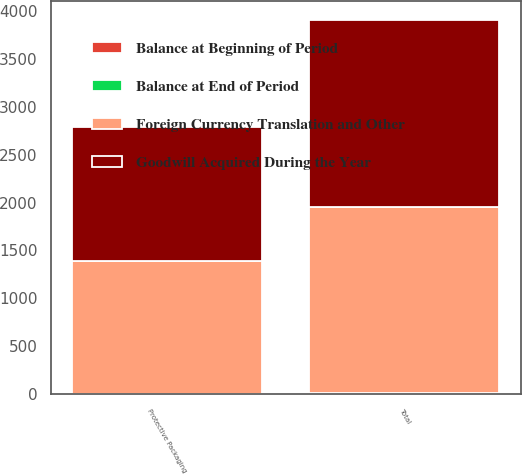Convert chart to OTSL. <chart><loc_0><loc_0><loc_500><loc_500><stacked_bar_chart><ecel><fcel>Protective Packaging<fcel>Total<nl><fcel>Foreign Currency Translation and Other<fcel>1392.3<fcel>1939.5<nl><fcel>Balance at End of Period<fcel>2.3<fcel>2.3<nl><fcel>Balance at Beginning of Period<fcel>0.2<fcel>11.6<nl><fcel>Goodwill Acquired During the Year<fcel>1394.8<fcel>1953.4<nl></chart> 